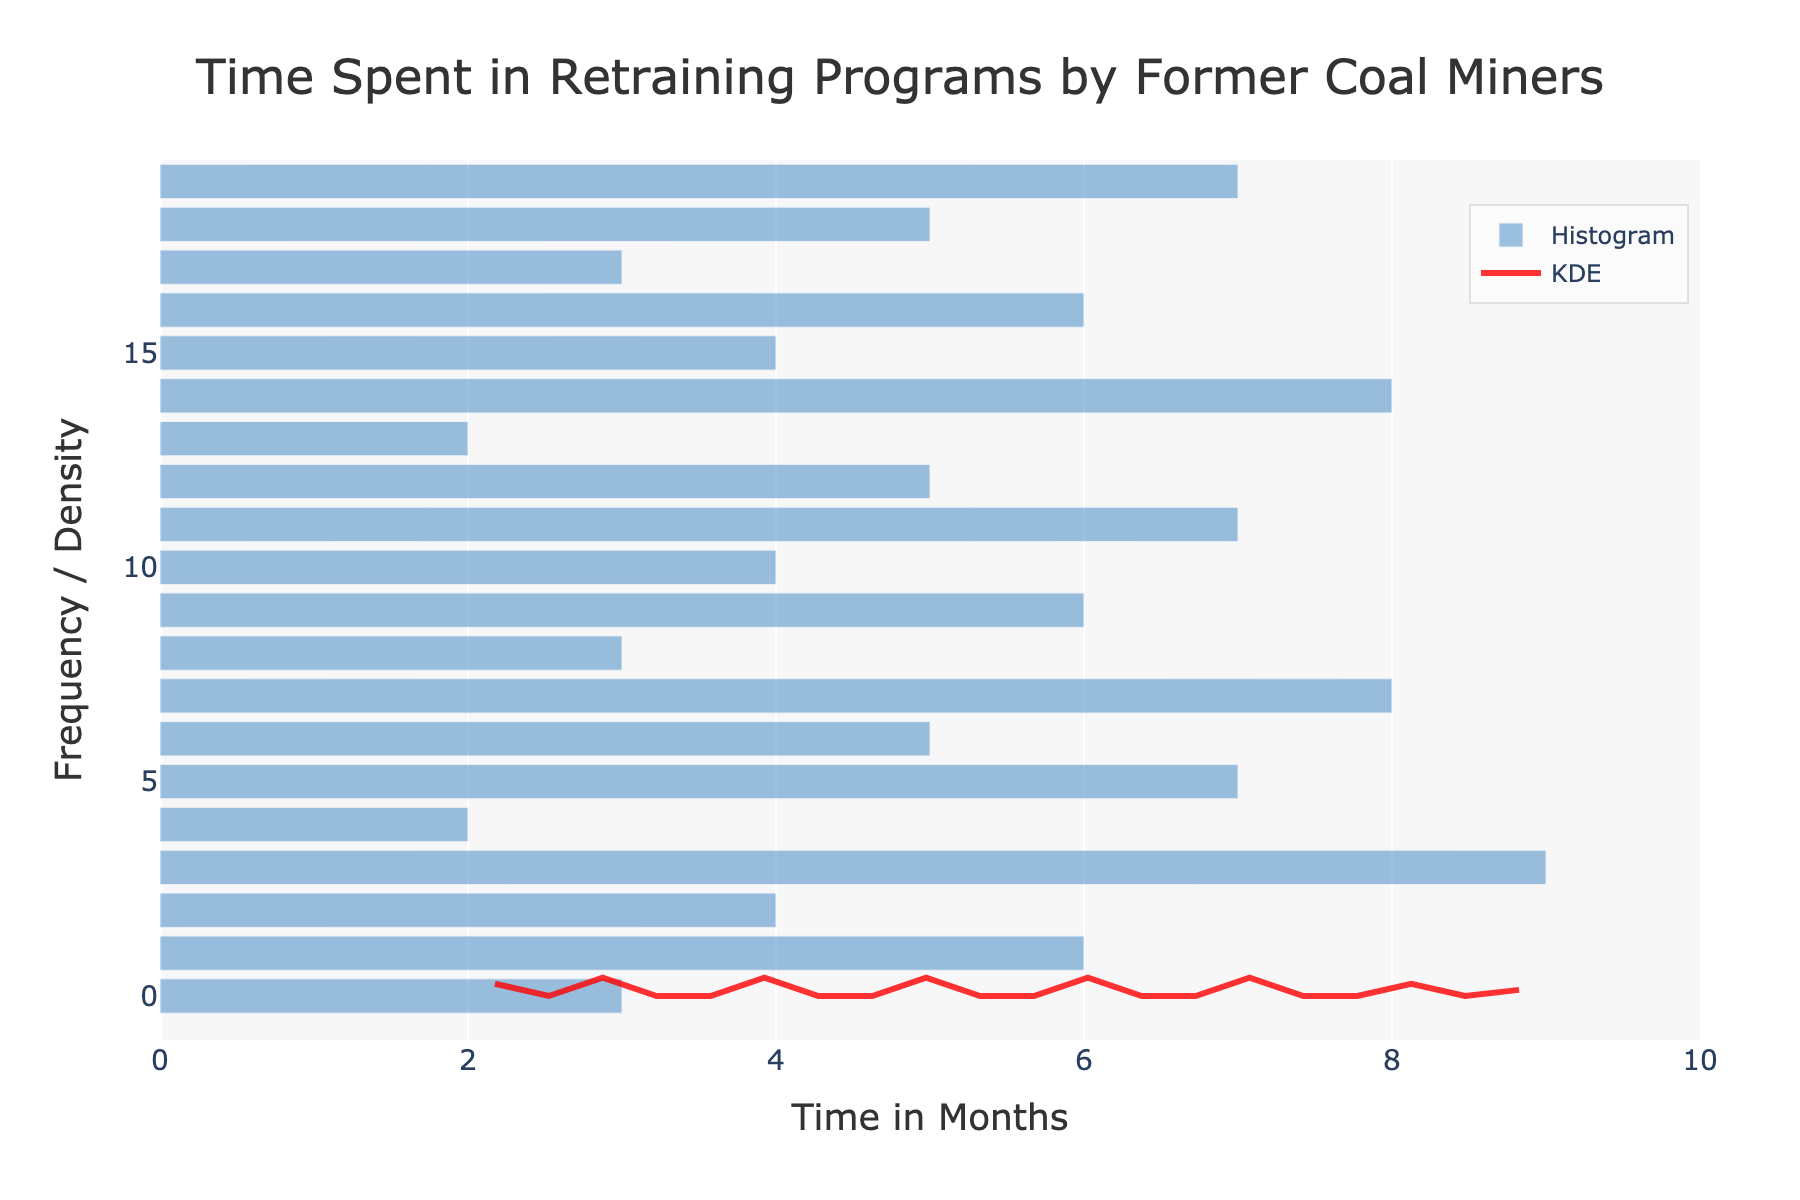What is the title of the figure? The title is typically displayed at the top of the figure. In this case, it reads "Time Spent in Retraining Programs by Former Coal Miners."
Answer: Time Spent in Retraining Programs by Former Coal Miners What is the range of the X-axis? The range of the X-axis can be observed from the plot, which starts from 0 and extends slightly beyond 9 months.
Answer: 0 to 10 months Which color represents the KDE curve? The KDE curve is represented by the lines in a distinct color, and in this case, it appears red.
Answer: Red What is the most frequent time spent in retraining programs? The histogram bars indicate frequency. The highest bar appears at 6 months, indicating it is the most frequent.
Answer: 6 months What is the average time spent in retraining programs? To find the average, sum all the time points and divide by the number of data points: (3+6+4+9+2+7+5+8+3+6+4+7+5+2+8+4+6+3+5+7)/20 = 5.1
Answer: 5.1 months Which retraining program had participants spending the shortest time? The shortest time on the X-axis is 2 months, corresponding to the "Virginia Coal to Solar Initiative" and "North Dakota Oil and Gas to Renewables" in the data provided.
Answer: Virginia Coal to Solar Initiative and North Dakota Oil and Gas to Renewables How does the number of participants spending 5 months compare to those spending 7 months in the retraining programs? By observing the height of the histogram bars, the bars representing 5 and 7 months are quite similar in height, suggesting comparable frequencies.
Answer: Comparable frequencies What time spent category corresponds to the peak of the KDE curve? The peak of the KDE (density) curve indicates the mode of the estimated density. The peak appears at around 5 to 6 months.
Answer: 5 to 6 months Is there a gap in the distribution of time spent for retraining programs? Based on the histogram, there is a noticeable gap between 9 months and the subsequent bar at 8 months, indicating a lower frequency.
Answer: Yes, around 9 months Are there any outliers in the time spent in retraining programs? Observing the histogram bars, times spent like 9 months appear less frequent than the other values, especially compared to the range around 5 to 7 months.
Answer: 9 months 